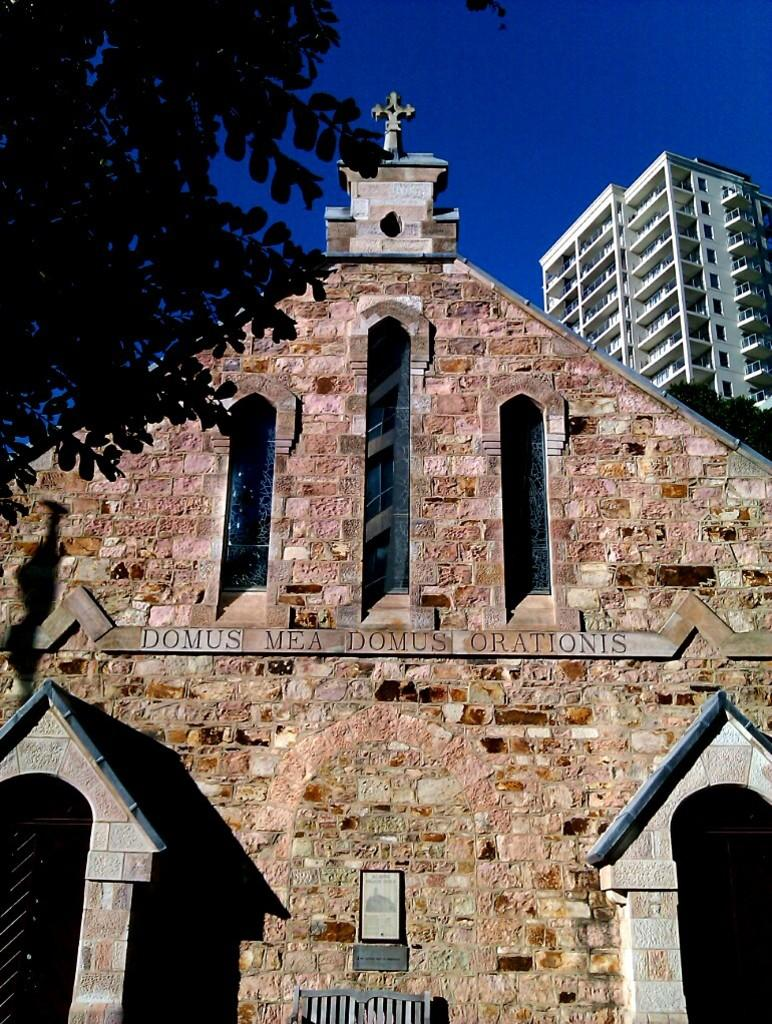What type of structures are present in the image? There are buildings in the image. Can you describe the object in the top left corner of the image? There is a branch in the top left corner of the image. What is visible at the top of the image? The sky is visible at the top of the image. What type of notebook can be seen on the windowsill of the building in the image? There is no notebook present in the image, nor is there a windowsill visible. 